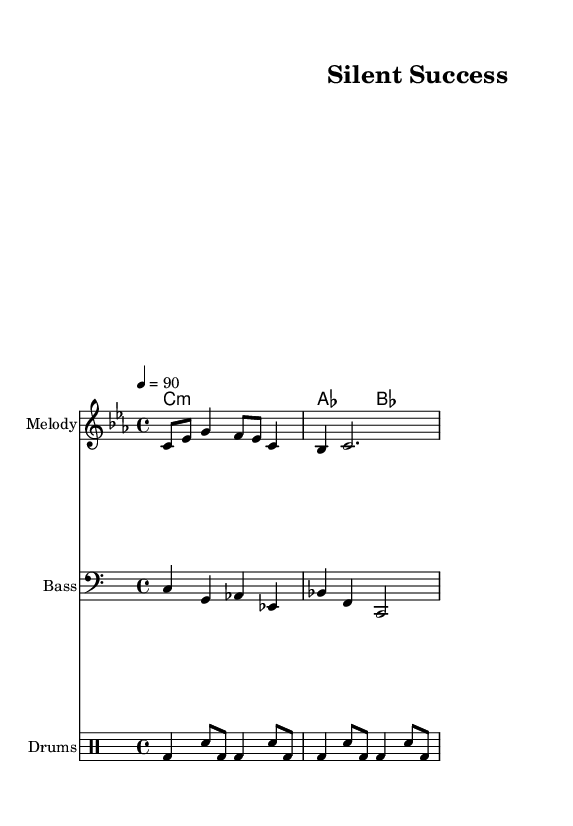What is the key signature of this music? The key signature is C minor, which has three flats (B, E, A). You can identify the key signature by looking at the beginning of the staff, where the flats are notated.
Answer: C minor What is the time signature of this music? The time signature is 4/4. This can be found at the beginning of the score, indicating that there are four beats in each measure and the quarter note gets one beat.
Answer: 4/4 What is the tempo marking for this piece? The tempo marking is 90 beats per minute. This is indicated in the score, providing the speed at which the music should be played, stated in terms of quarter notes.
Answer: 90 What type of musical form does the piece follow? The piece follows a verse-chorus structure, which is common in rap and hip-hop music. This structure is evident in the lyrics and the rhythm, emphasizing the inspirational message.
Answer: Verse-Chorus What is the primary instrument used in the melody? The primary instrument used in the melody is labeled as "Melody" in the score. The notes are written in the treble clef, which denotes the specific part for an instrument or voice to perform.
Answer: Melody How is the drum beat structured in this rap piece? The drum beat is structured with alternating bass and snare hits that create a steady rhythm and drive the rap. Analyzing the drum notation, you can see the pattern of beats that provides the backbone for the rap.
Answer: Alternating bass and snare 